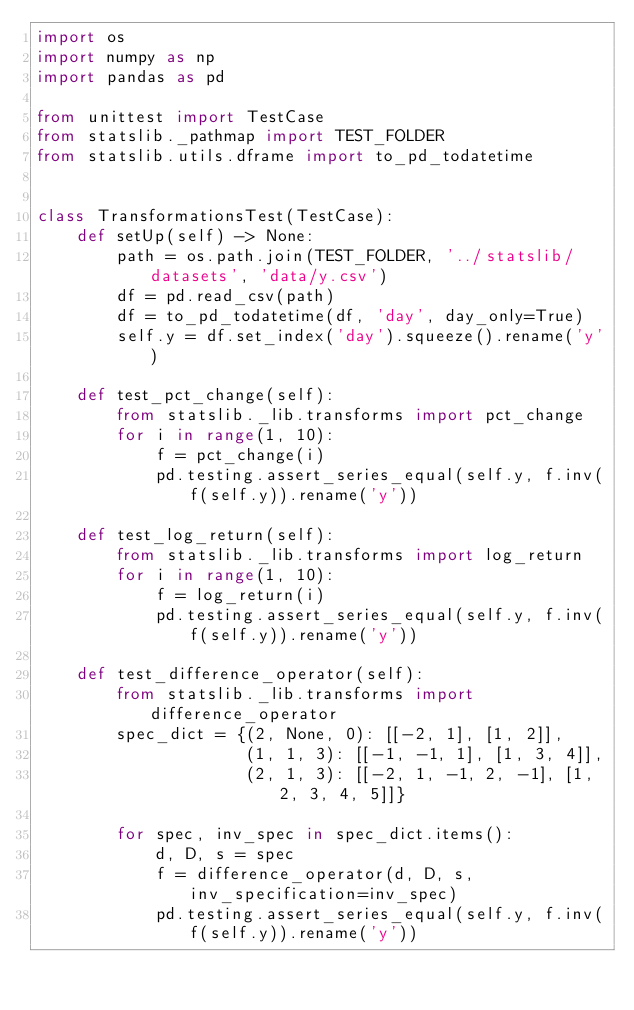Convert code to text. <code><loc_0><loc_0><loc_500><loc_500><_Python_>import os
import numpy as np
import pandas as pd

from unittest import TestCase
from statslib._pathmap import TEST_FOLDER
from statslib.utils.dframe import to_pd_todatetime


class TransformationsTest(TestCase):
    def setUp(self) -> None:
        path = os.path.join(TEST_FOLDER, '../statslib/datasets', 'data/y.csv')
        df = pd.read_csv(path)
        df = to_pd_todatetime(df, 'day', day_only=True)
        self.y = df.set_index('day').squeeze().rename('y')

    def test_pct_change(self):
        from statslib._lib.transforms import pct_change
        for i in range(1, 10):
            f = pct_change(i)
            pd.testing.assert_series_equal(self.y, f.inv(f(self.y)).rename('y'))

    def test_log_return(self):
        from statslib._lib.transforms import log_return
        for i in range(1, 10):
            f = log_return(i)
            pd.testing.assert_series_equal(self.y, f.inv(f(self.y)).rename('y'))

    def test_difference_operator(self):
        from statslib._lib.transforms import difference_operator
        spec_dict = {(2, None, 0): [[-2, 1], [1, 2]],
                     (1, 1, 3): [[-1, -1, 1], [1, 3, 4]],
                     (2, 1, 3): [[-2, 1, -1, 2, -1], [1, 2, 3, 4, 5]]}

        for spec, inv_spec in spec_dict.items():
            d, D, s = spec
            f = difference_operator(d, D, s, inv_specification=inv_spec)
            pd.testing.assert_series_equal(self.y, f.inv(f(self.y)).rename('y'))
</code> 